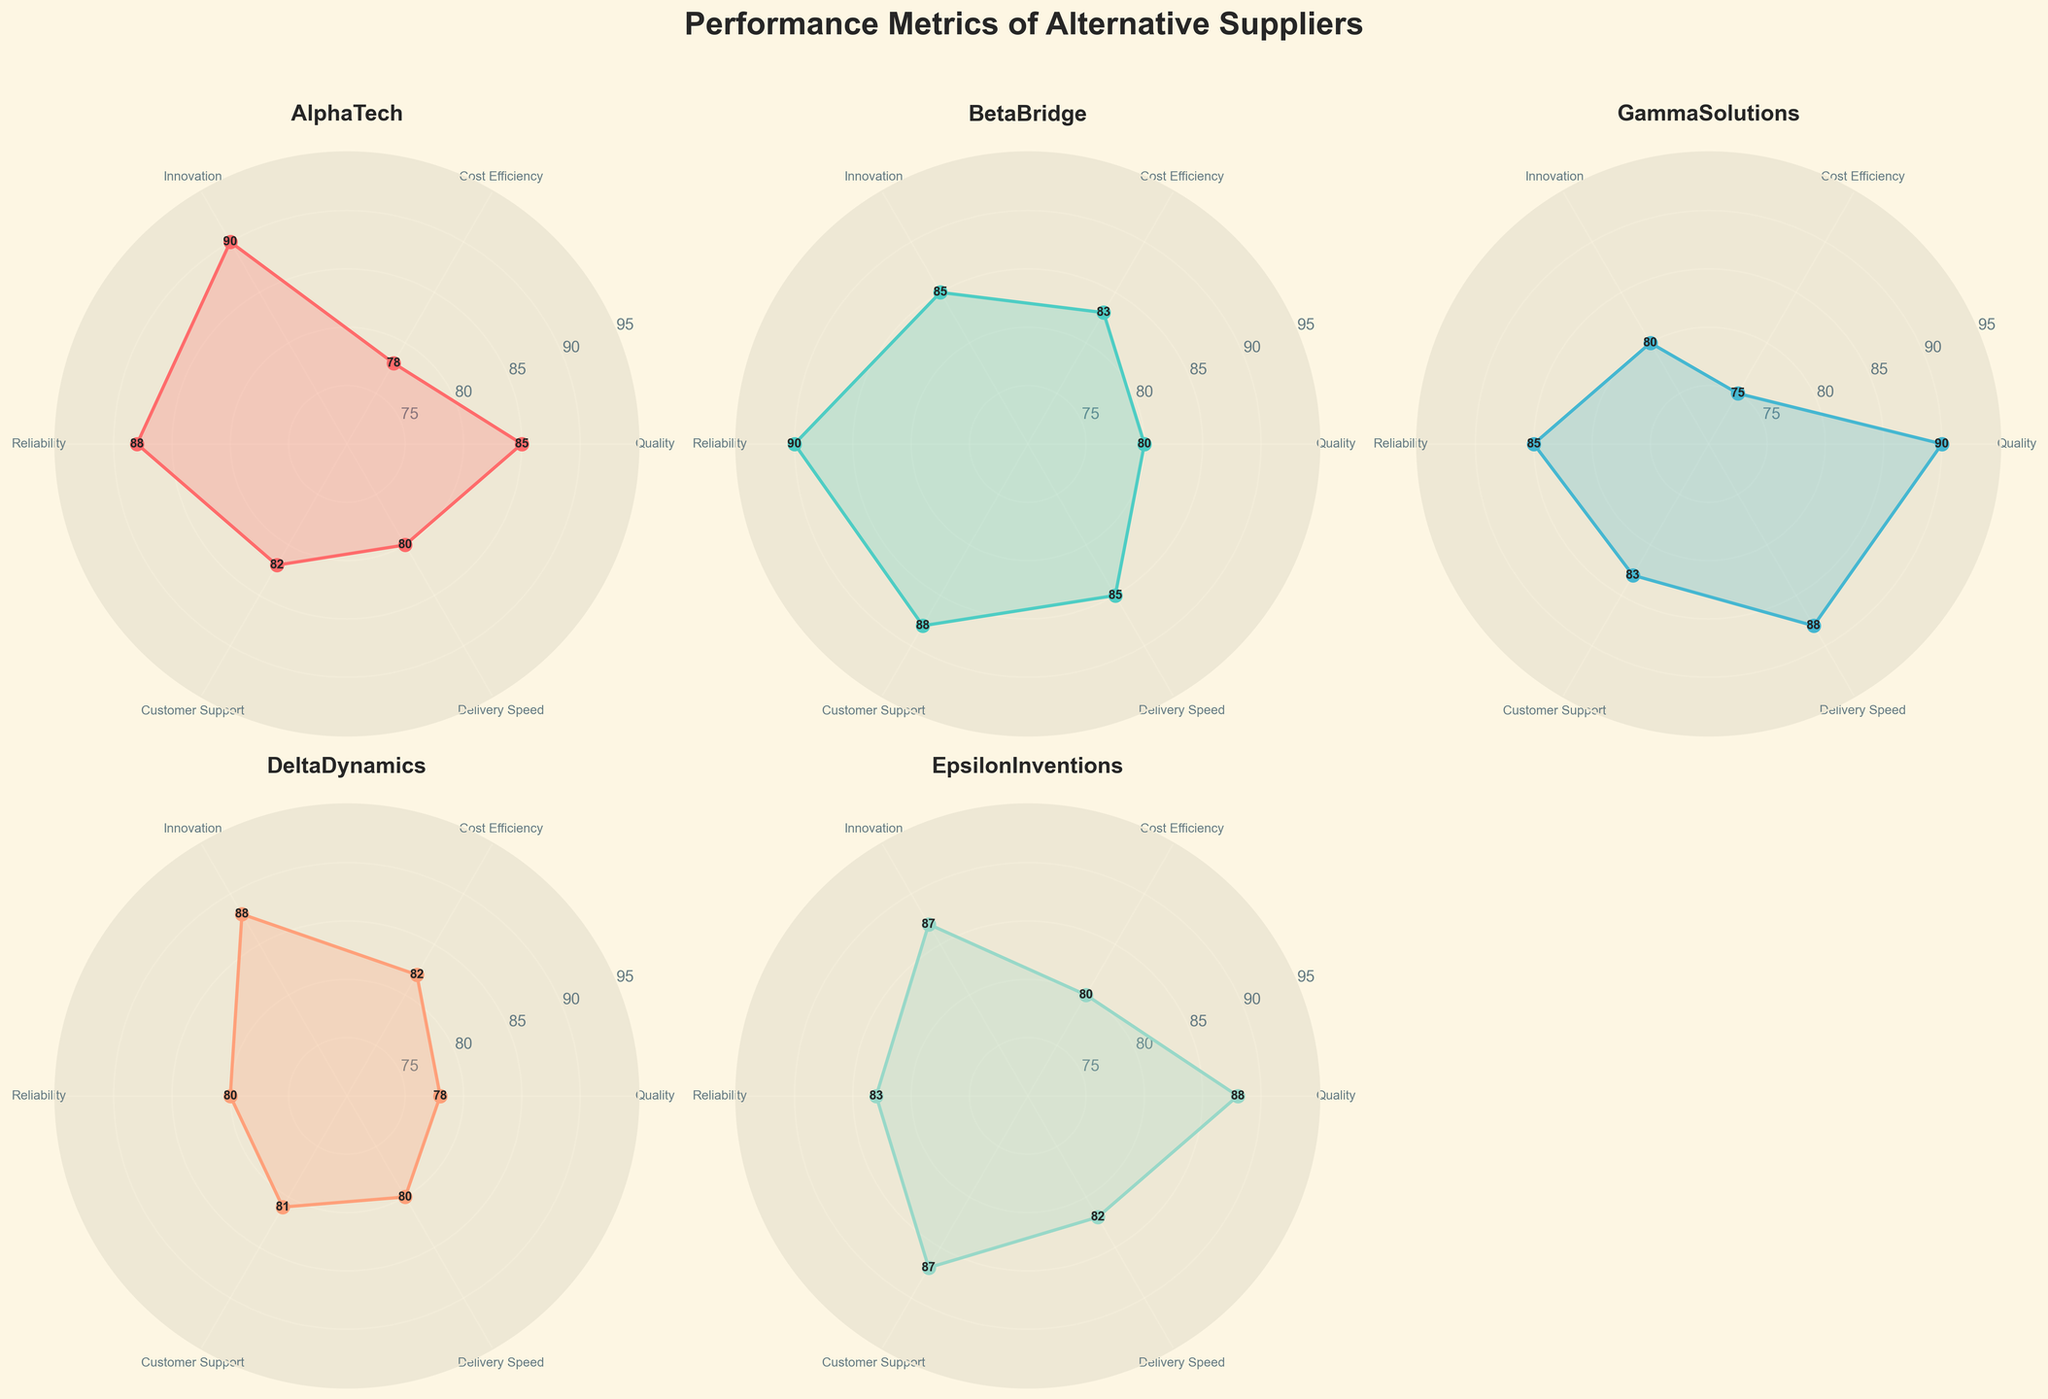What is the title of the figure? The title of the figure is written at the top, outside the subplots, in a larger and bolder font compared to the rest of the text.
Answer: Performance Metrics of Alternative Suppliers How many suppliers are displayed in the radar chart? Each subplot represents a different supplier. The figure contains 5 subplots.
Answer: 5 Which supplier has the highest Delivery Speed score? By examining the "Delivery Speed" values close to each supplier's subplot, GammaSolutions has the highest value.
Answer: GammaSolutions What is the average Innovation score across all suppliers? Add up the Innovation scores of all suppliers (90 + 85 + 80 + 88 + 87) and divide by the number of suppliers (5). (90 + 85 + 80 + 88 + 87) / 5 = 86
Answer: 86 Which supplier has the lowest score in any category, and what is that score? Look for the lowest point on each of the suppliers' radial plots. AlphaTech has the lowest score at 78 in Cost Efficiency.
Answer: AlphaTech, 78 How do the Customer Support scores of BetaBridge and EpsilonInventions compare? Compare the Customer Support values for BetaBridge (88) and EpsilonInventions (87). BetaBridge has a slightly higher score.
Answer: BetaBridge is higher What is the range of Reliability scores among all suppliers? Find the highest and lowest Reliability scores. The highest is 90 (BetaBridge), and the lowest is 80 (GammaSolutions). The range is 90 - 80 = 10.
Answer: 10 Which supplier has the most evenly distributed performance across all metrics? Check the consistency of the values across all categories in each subplot. EpsilonInventions has relatively close scores across the board (88, 80, 87, 83, 87, 82).
Answer: EpsilonInventions Compare the Cost Efficiency scores between AlphaTech and GammaSolutions. Which one is higher, and by how much? Compare the Cost Efficiency values for AlphaTech (78) and GammaSolutions (75). AlphaTech has a higher score by 3 points (78 - 75 = 3).
Answer: AlphaTech is higher by 3 